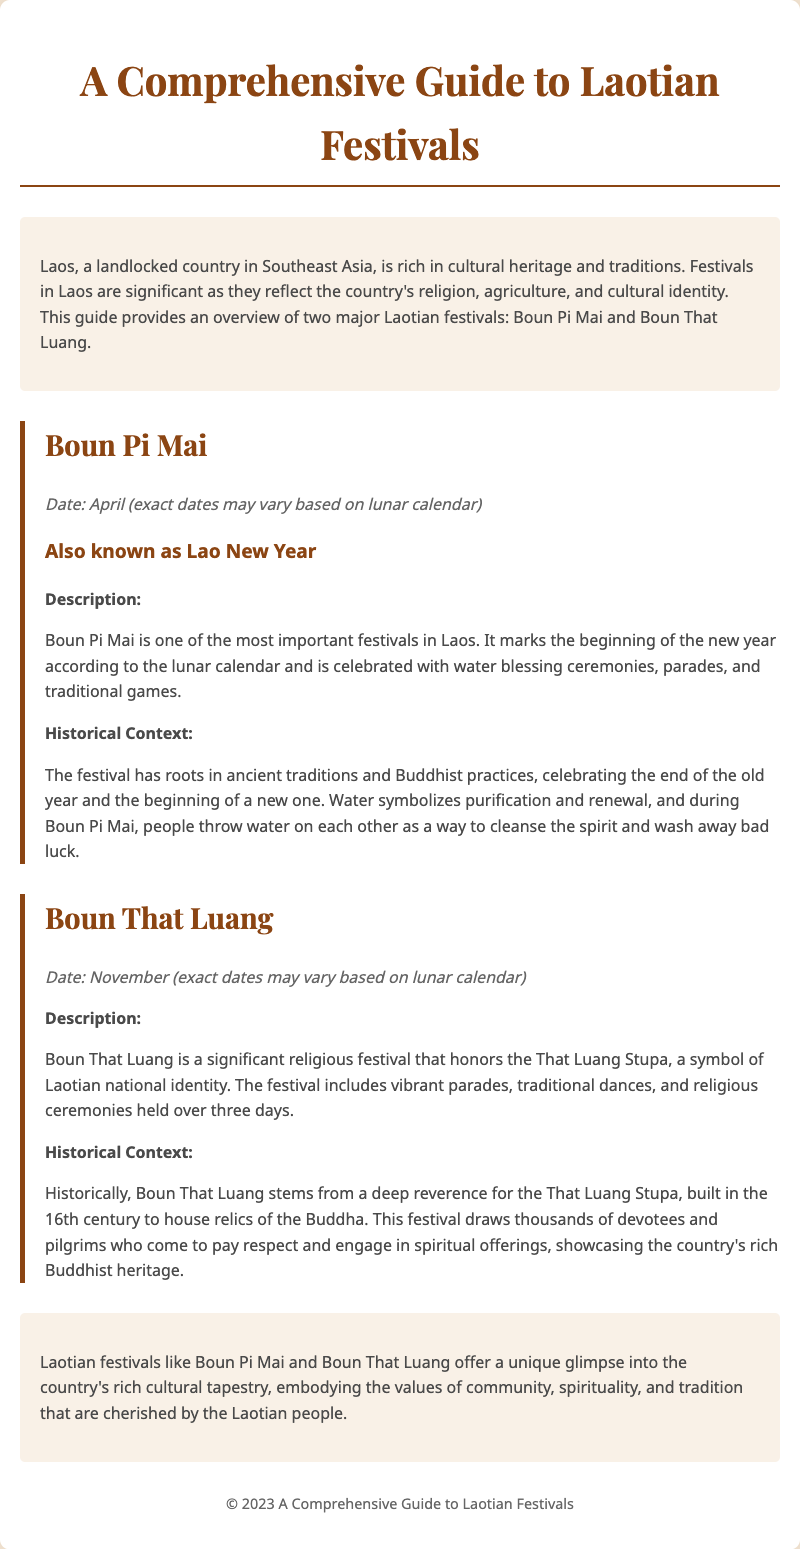what is the date of Boun Pi Mai? The document states that Boun Pi Mai is celebrated in April, with exact dates varying based on the lunar calendar.
Answer: April what is another name for Boun Pi Mai? The document mentions that Boun Pi Mai is also known as Lao New Year.
Answer: Lao New Year how long does the Boun That Luang festival last? Based on the information in the document, Boun That Luang is held over three days.
Answer: three days what is significant about the That Luang Stupa? The document indicates that the That Luang Stupa is a symbol of Laotian national identity.
Answer: symbol of Laotian national identity what type of ceremonies are associated with Boun Pi Mai? The document describes water blessing ceremonies as part of the Boun Pi Mai celebrations.
Answer: water blessing ceremonies what aspect of Laotian culture do these festivals reflect? According to the document, Laotian festivals reflect the country's religion, agriculture, and cultural identity.
Answer: religion, agriculture, and cultural identity what does water symbolize during Boun Pi Mai? The document states that water symbolizes purification and renewal during the celebration.
Answer: purification and renewal when does Boun That Luang typically occur? The document notes that Boun That Luang takes place in November, with dates varying based on the lunar calendar.
Answer: November 